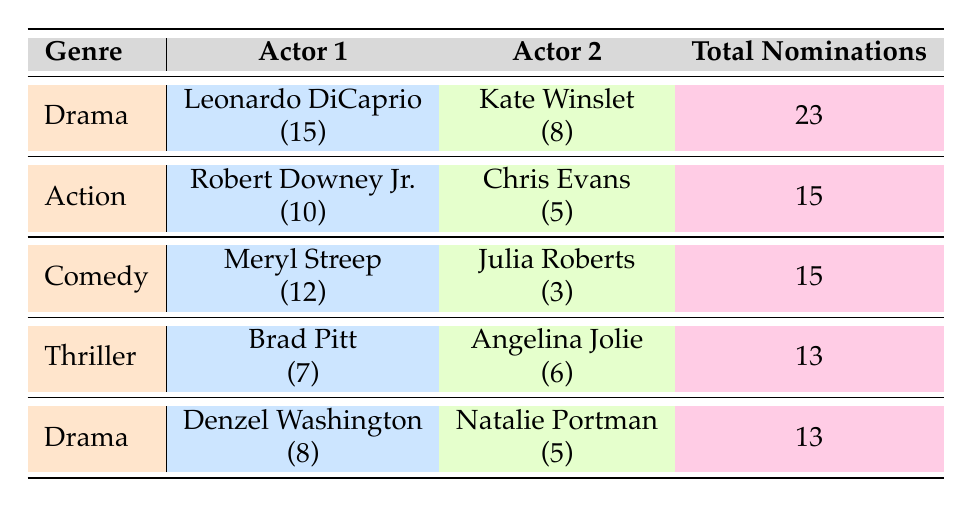What is the total number of award nominations for Leonardo DiCaprio and Kate Winslet in the Drama genre? The table lists Leonardo DiCaprio with 15 and Kate Winslet with 8 nominations. Adding these together gives 15 + 8 = 23 total nominations.
Answer: 23 Which actor has the highest number of award nominations in the table? Reviewing each actor's nominations: Leonardo DiCaprio has 15, Meryl Streep has 12, Robert Downey Jr. has 10, and others have less. Thus, Leonardo DiCaprio has the highest nominations at 15.
Answer: Leonardo DiCaprio Is there an actor from the Comedy genre with more than 10 award nominations? Looking at the Comedy genre, Meryl Streep has 12 nominations, which is more than 10. Therefore, the answer is yes.
Answer: Yes What is the difference in total award nominations between the Action genre and the Thriller genre? The total nominations for Action is 15 (Robert Downey Jr. and Chris Evans) and for Thriller is 13 (Brad Pitt and Angelina Jolie). The difference is 15 - 13 = 2.
Answer: 2 How many total nominations do the actors in Drama genre have? The Drama genre includes Leonardo DiCaprio with 15, Kate Winslet with 8, Denzel Washington with 8, and Natalie Portman with 5. Summing these gives 15 + 8 + 8 + 5 = 36.
Answer: 36 Which genre has the least total nominations among the pairs listed? Calculating the total nominations for each genre: Drama has 23 + 13 = 36, Action has 15, Comedy has 15, and Thriller has 13. The Thriller genre has the least total nominations.
Answer: Thriller Is Chris Evans’ award nomination count higher than Angelina Jolie’s? Chris Evans has 5 nominations, while Angelina Jolie has 6. Therefore, Chris Evans' count is not higher than Angelina Jolie’s.
Answer: No Who are the two actors with the most nominations in the table, and what is their total? The two highest are Leonardo DiCaprio with 15 and Meryl Streep with 12. Adding these gives 15 + 12 = 27.
Answer: 27 What is the average number of award nominations for the actors in the Comedy genre? In the Comedy genre, the nominations are 12 (Meryl Streep) and 3 (Julia Roberts). The average is calculated as (12 + 3) / 2 = 15 / 2 = 7.5.
Answer: 7.5 